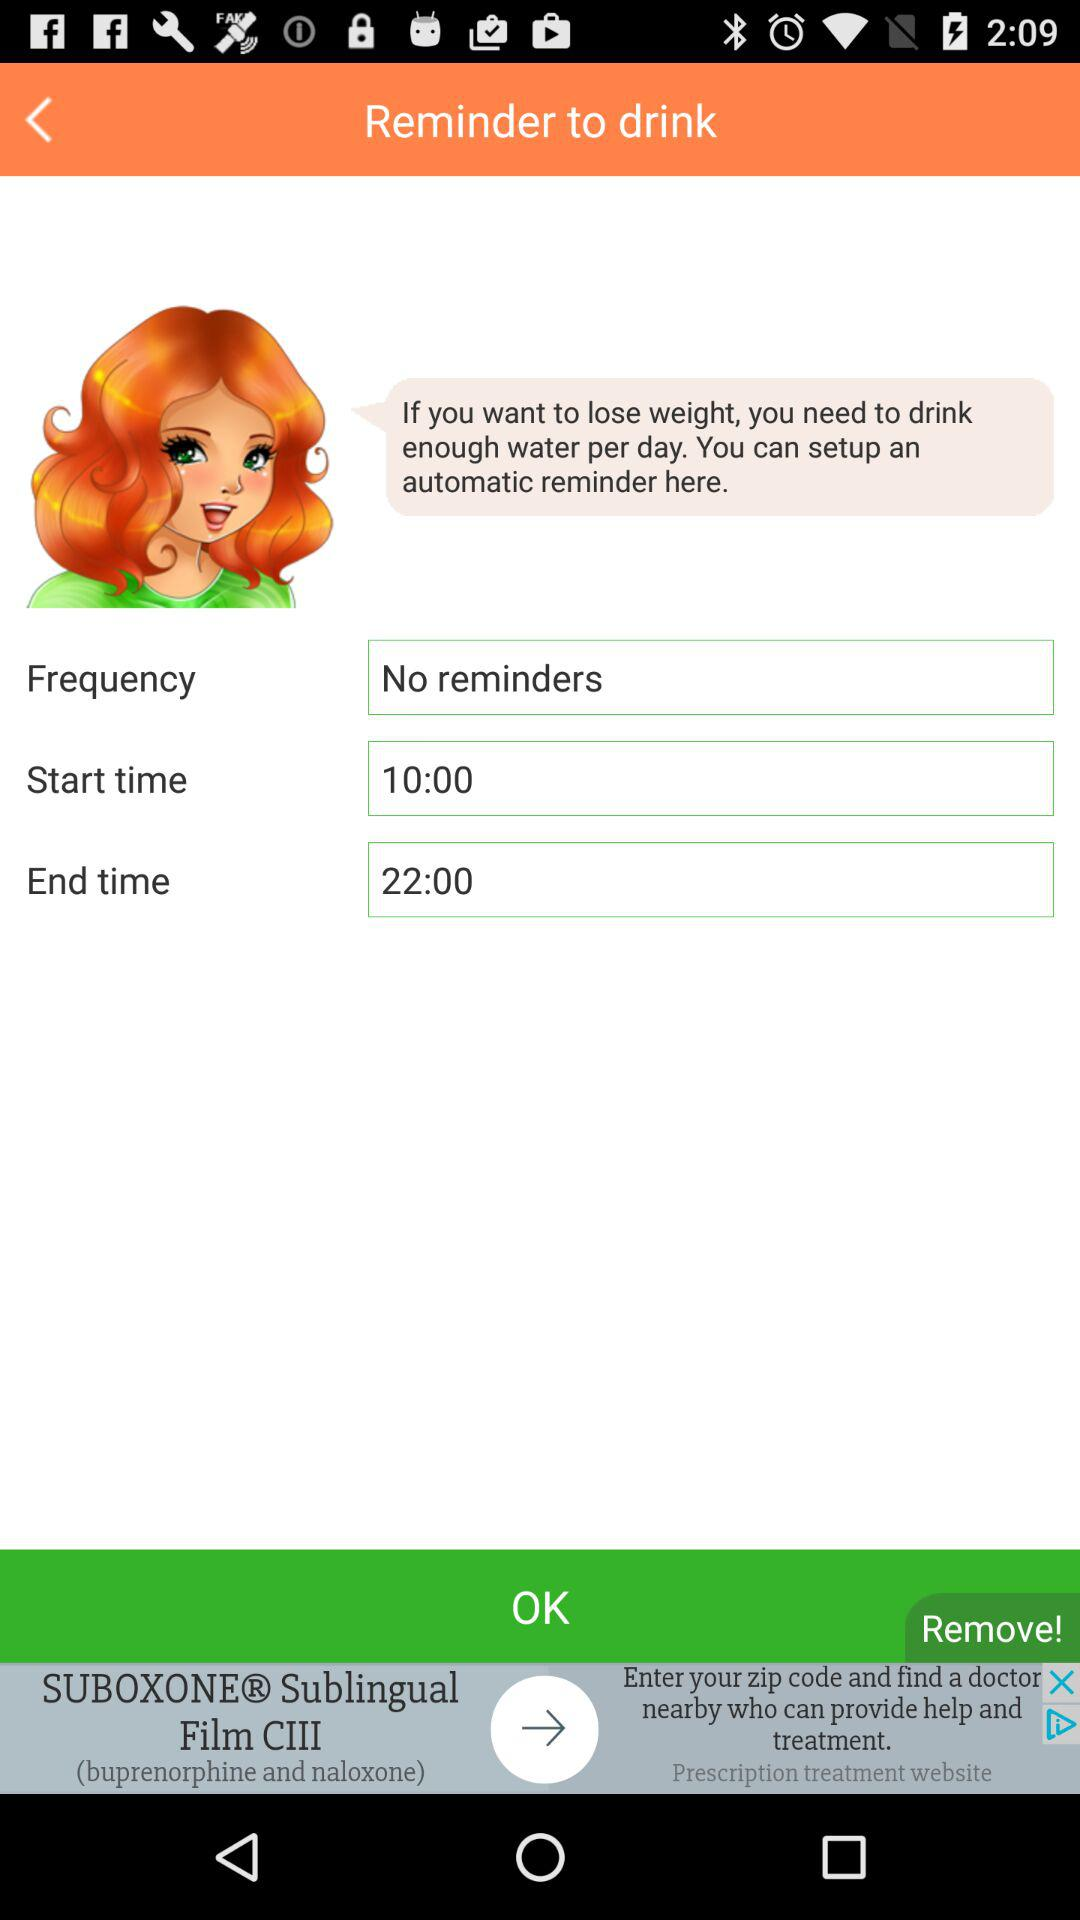Is there any reminder set? There is no reminder set. 